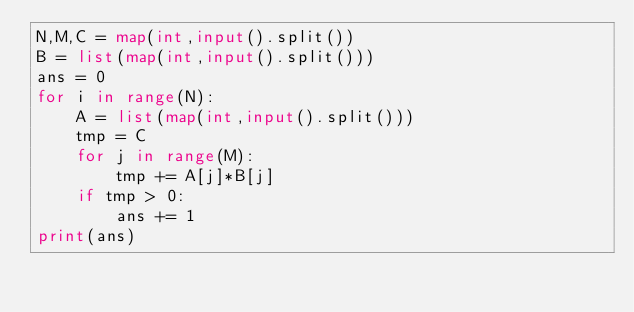<code> <loc_0><loc_0><loc_500><loc_500><_Python_>N,M,C = map(int,input().split())
B = list(map(int,input().split()))
ans = 0
for i in range(N):
    A = list(map(int,input().split()))
    tmp = C
    for j in range(M):
        tmp += A[j]*B[j]
    if tmp > 0:
        ans += 1
print(ans)

    
</code> 